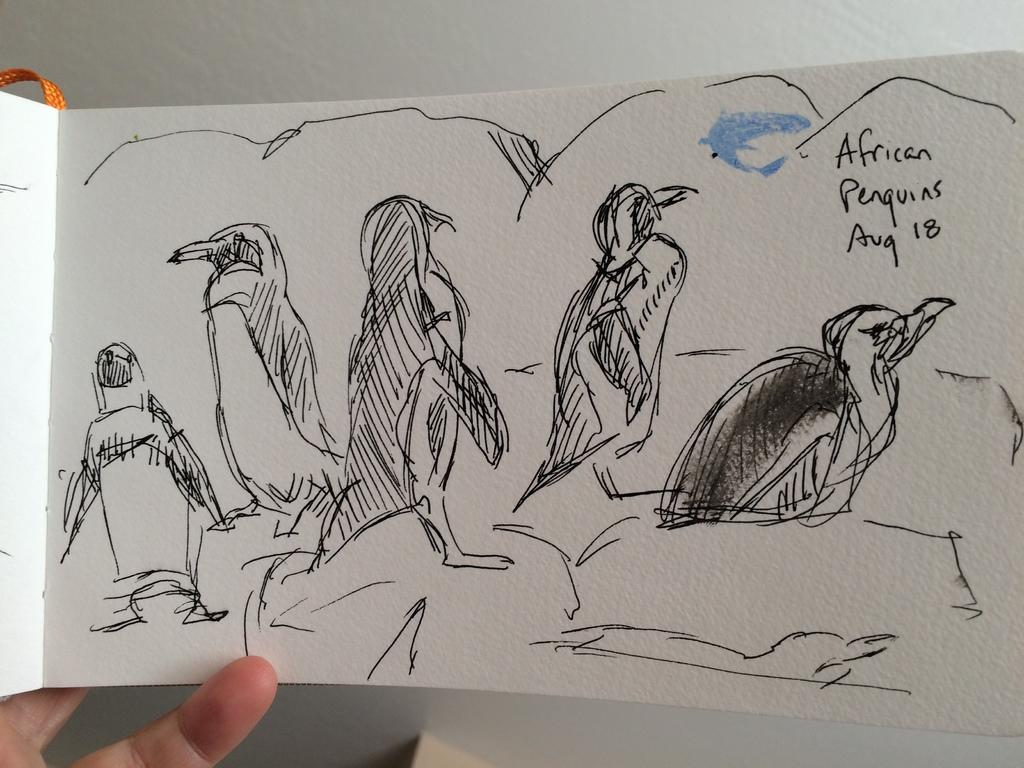What is depicted on the paper in the image? There is a sketch of animals on the paper. What is the color of the paper? The paper is white. Who is holding the paper in the image? A person is holding the paper. What can be seen in the background of the image? The background is white. What type of shoes is the person wearing in the image? There is no information about shoes in the image, as the focus is on the sketch of animals and the person holding the paper. 